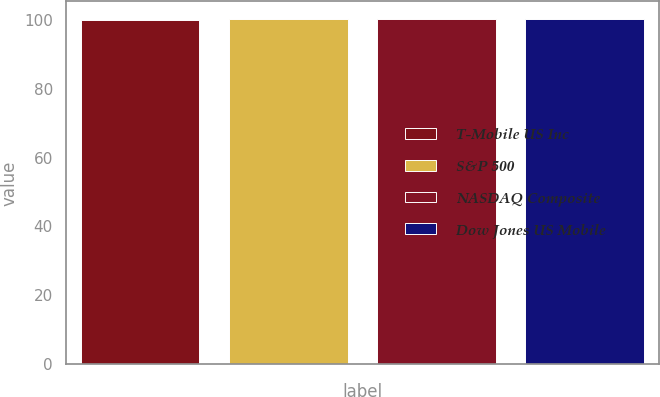Convert chart. <chart><loc_0><loc_0><loc_500><loc_500><bar_chart><fcel>T-Mobile US Inc<fcel>S&P 500<fcel>NASDAQ Composite<fcel>Dow Jones US Mobile<nl><fcel>100<fcel>100.1<fcel>100.2<fcel>100.3<nl></chart> 